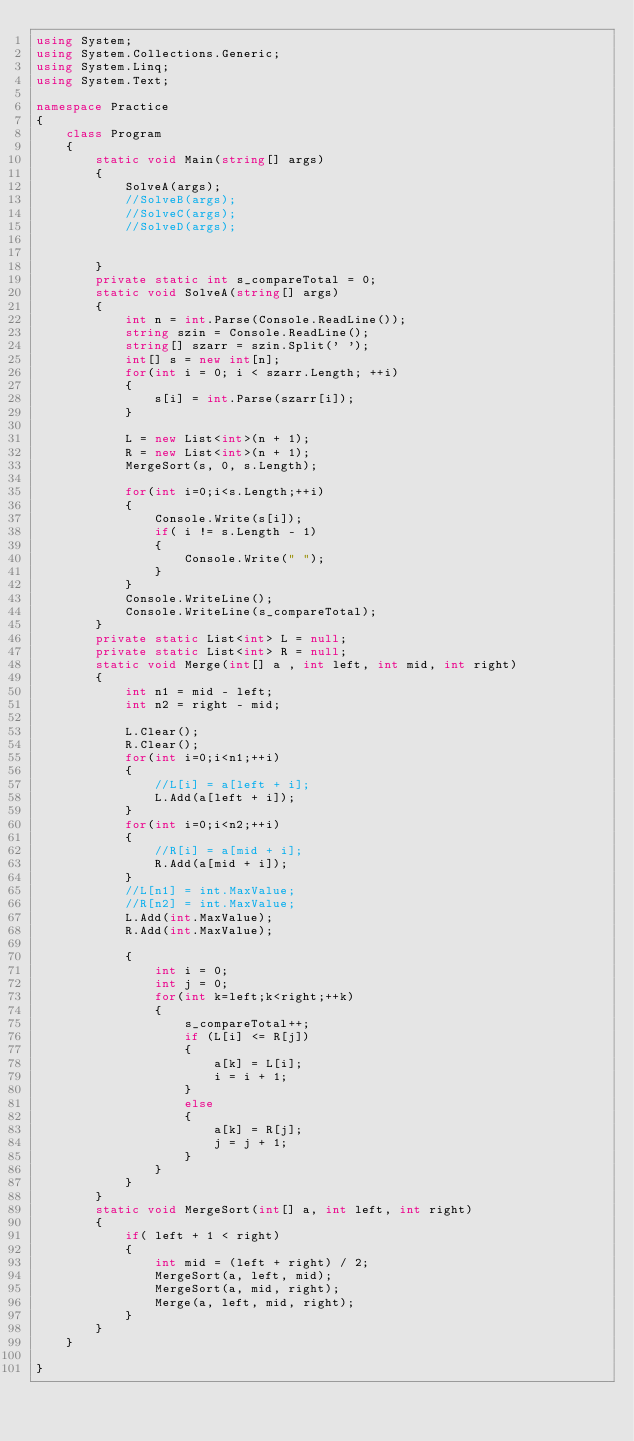Convert code to text. <code><loc_0><loc_0><loc_500><loc_500><_C#_>using System;
using System.Collections.Generic;
using System.Linq;
using System.Text;

namespace Practice
{
    class Program
    {
        static void Main(string[] args)
        {
            SolveA(args);
            //SolveB(args);
            //SolveC(args);
            //SolveD(args);


        }
        private static int s_compareTotal = 0;
        static void SolveA(string[] args)
        {
            int n = int.Parse(Console.ReadLine());
            string szin = Console.ReadLine();
            string[] szarr = szin.Split(' ');
            int[] s = new int[n];
            for(int i = 0; i < szarr.Length; ++i)
            {
                s[i] = int.Parse(szarr[i]);
            }

            L = new List<int>(n + 1);
            R = new List<int>(n + 1);
            MergeSort(s, 0, s.Length);

            for(int i=0;i<s.Length;++i)
            {
                Console.Write(s[i]);
                if( i != s.Length - 1)
                {
                    Console.Write(" ");
                }
            }
            Console.WriteLine();
            Console.WriteLine(s_compareTotal);
        }
        private static List<int> L = null;
        private static List<int> R = null;
        static void Merge(int[] a , int left, int mid, int right)
        {
            int n1 = mid - left;
            int n2 = right - mid;

            L.Clear();
            R.Clear();
            for(int i=0;i<n1;++i)
            {
                //L[i] = a[left + i];
                L.Add(a[left + i]);
            }
            for(int i=0;i<n2;++i)
            {
                //R[i] = a[mid + i];
                R.Add(a[mid + i]);
            }
            //L[n1] = int.MaxValue;
            //R[n2] = int.MaxValue;
            L.Add(int.MaxValue);
            R.Add(int.MaxValue);

            {
                int i = 0;
                int j = 0;
                for(int k=left;k<right;++k)
                {
                    s_compareTotal++;
                    if (L[i] <= R[j])
                    {
                        a[k] = L[i];
                        i = i + 1;
                    }
                    else
                    {
                        a[k] = R[j];
                        j = j + 1;
                    }
                }
            }
        }
        static void MergeSort(int[] a, int left, int right)
        {
            if( left + 1 < right)
            {
                int mid = (left + right) / 2;
                MergeSort(a, left, mid);
                MergeSort(a, mid, right);
                Merge(a, left, mid, right);
            }
        }
    }

}

</code> 